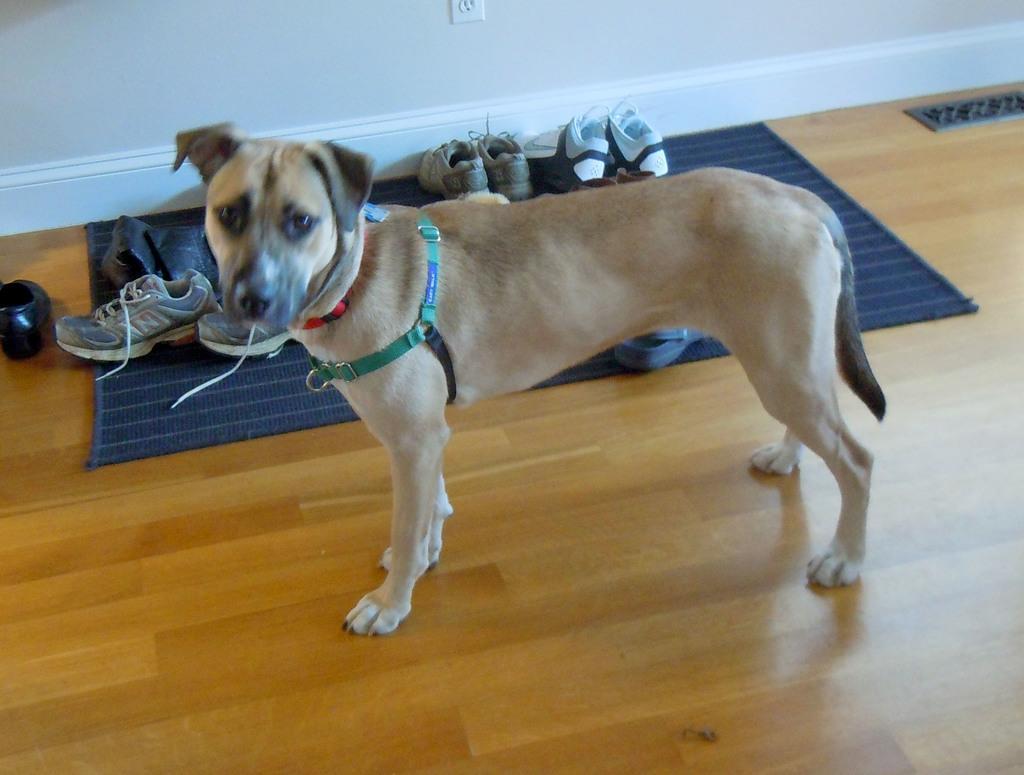Describe this image in one or two sentences. In this image we can see a dog on the floor and behind there is a mat and on the mat, we can see few shoes and in the background, we can see the wall. 